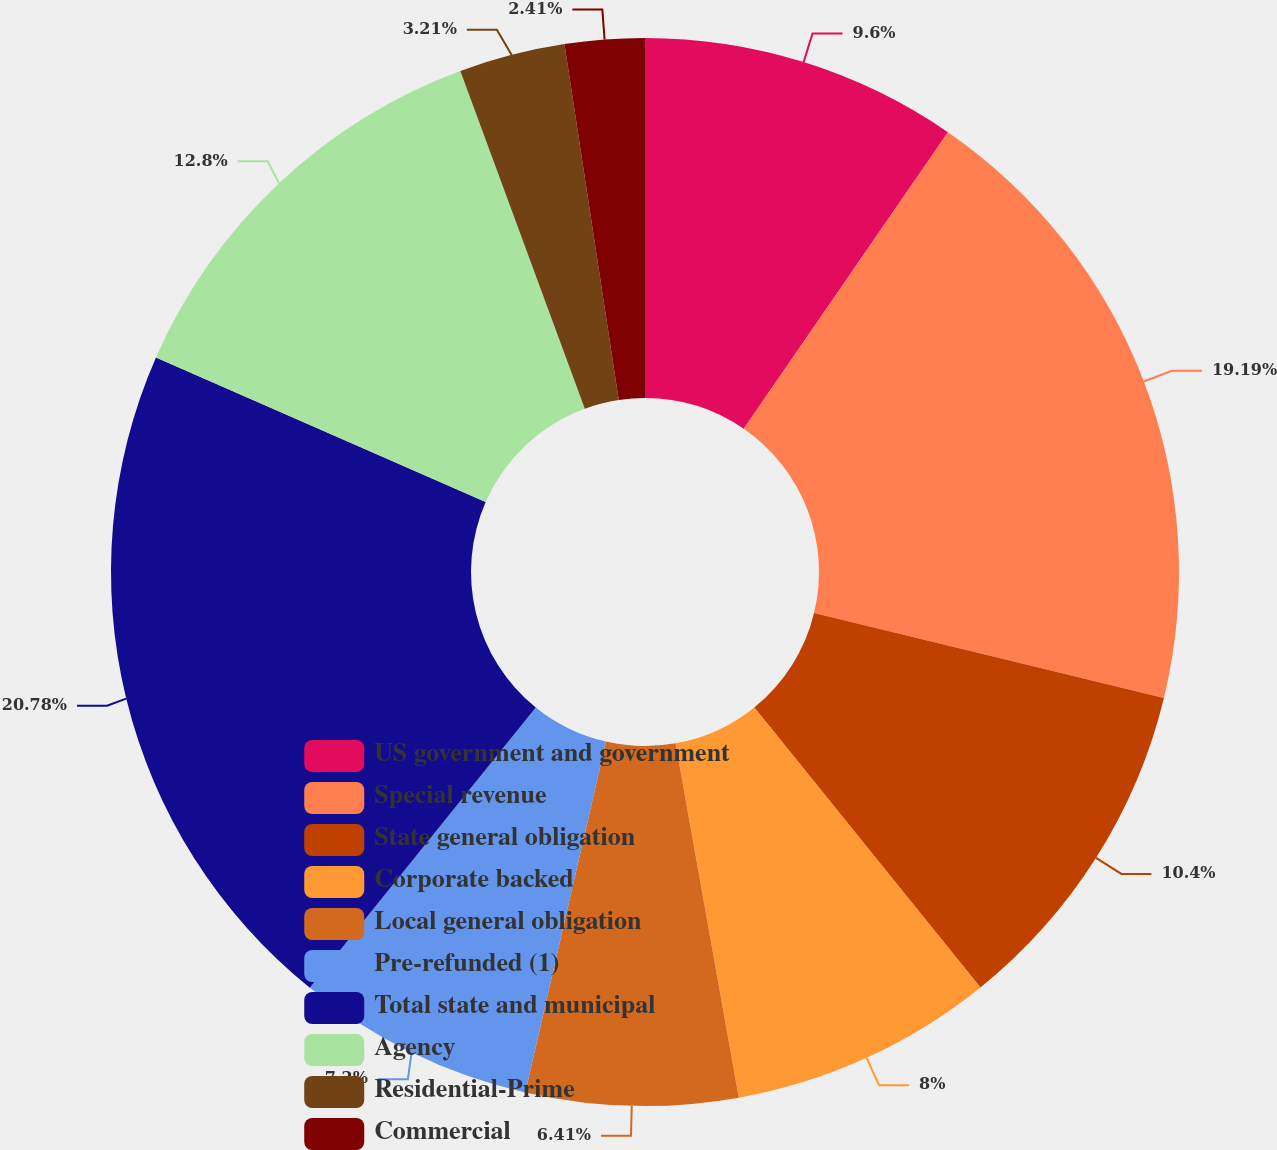Convert chart to OTSL. <chart><loc_0><loc_0><loc_500><loc_500><pie_chart><fcel>US government and government<fcel>Special revenue<fcel>State general obligation<fcel>Corporate backed<fcel>Local general obligation<fcel>Pre-refunded (1)<fcel>Total state and municipal<fcel>Agency<fcel>Residential-Prime<fcel>Commercial<nl><fcel>9.6%<fcel>19.19%<fcel>10.4%<fcel>8.0%<fcel>6.41%<fcel>7.2%<fcel>20.78%<fcel>12.8%<fcel>3.21%<fcel>2.41%<nl></chart> 